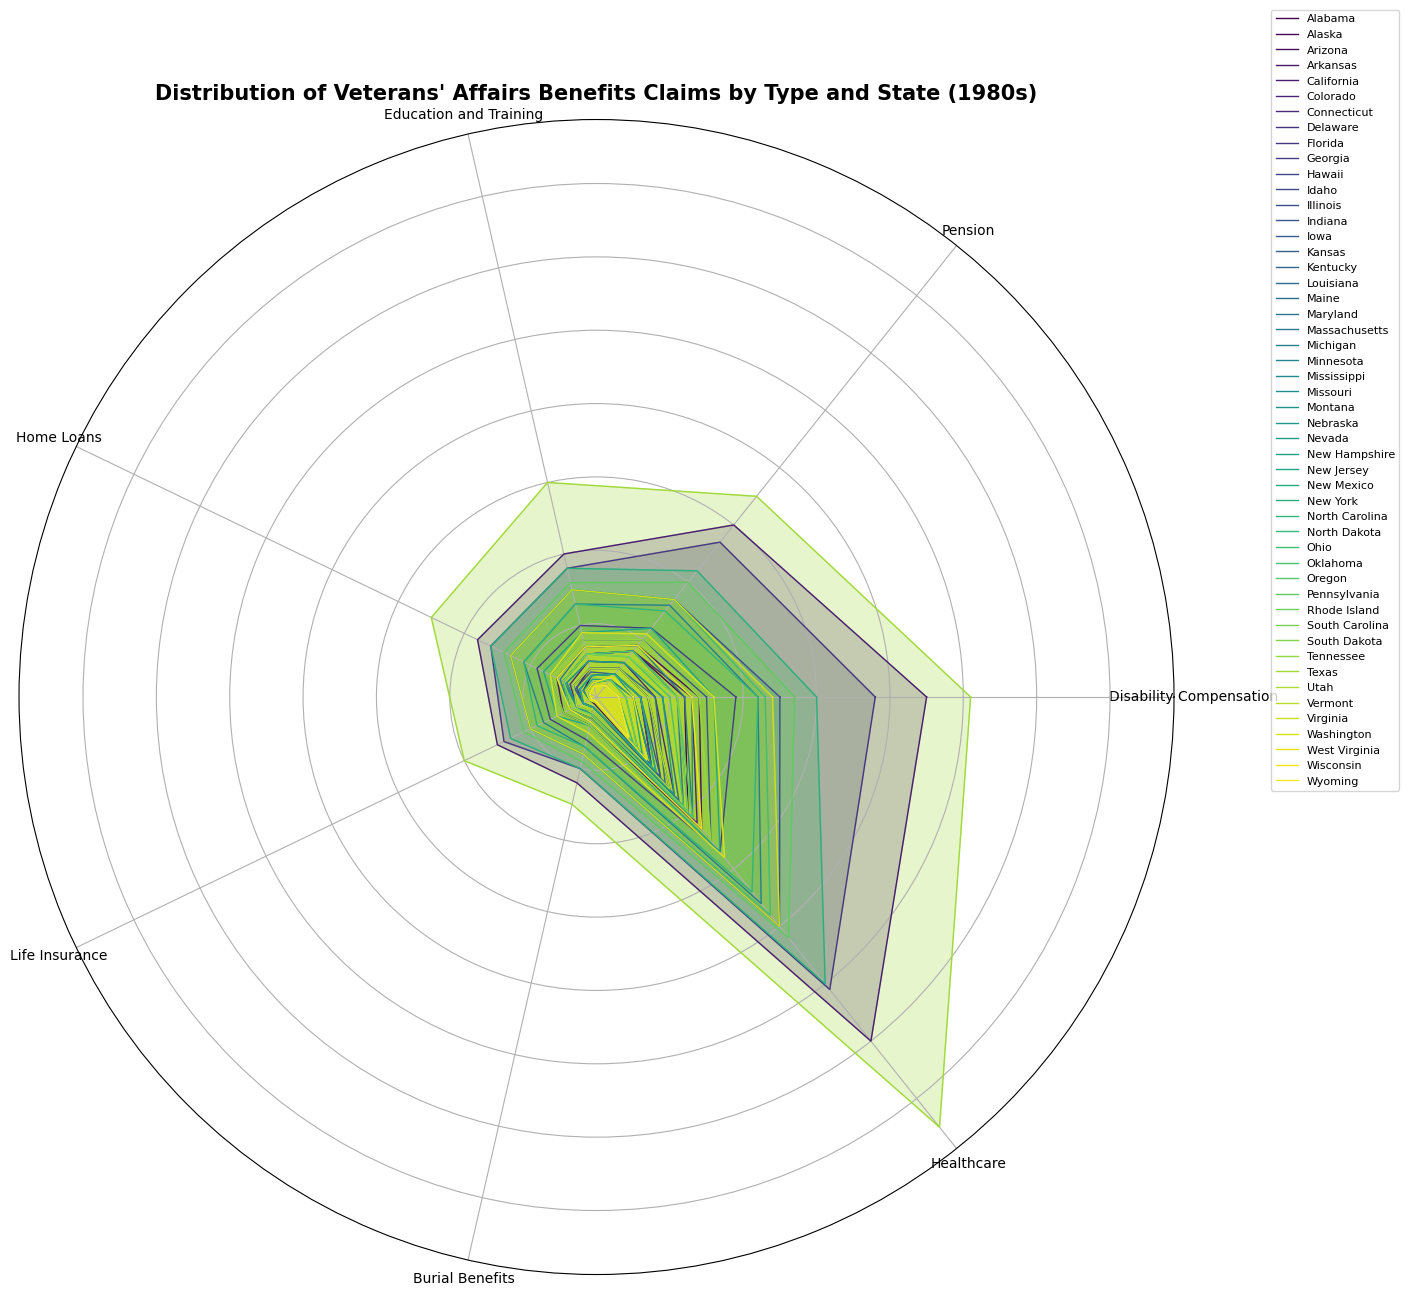What's the state with the highest total veterans' benefits claims? To find this, observe the overall size of each individual state's shape in the rose chart. The state with the largest shape represents the highest total claims.
Answer: Texas How do the Healthcare benefits claims compare between California and Texas? Identify the sections of the rose chart that represent Healthcare benefits for both California and Texas and compare their lengths.
Answer: Texas has higher Healthcare claims than California Which state claims more Disability Compensation benefits, Florida or New York? Locate the Disability Compensation sections for Florida and New York on the rose chart and compare their lengths.
Answer: Florida What is the combined total of Home Loans and Life Insurance benefits claims for Georgia? Identify the lengths of the Home Loans and Life Insurance sections in the rose chart for Georgia, then add them together.
Answer: 1600 Which benefit type has the smallest difference in claims between Indiana and Illinois? Observe the sections of the rose chart for Indiana and Illinois and compare the differences in length for each benefit type.
Answer: Education and Training Is the Pension claims section bigger for Alabama or Massachusetts? Locate the Pension section for both Alabama and Massachusetts in the rose chart and compare their lengths.
Answer: Massachusetts Which state has the most balanced distribution of benefits claims (similar lengths for all benefit types)? Look for a state in the rose chart where all segments seem to have nearly equal lengths.
Answer: Alaska How does the total number of Education and Training benefits claims compare between Arkansas and Tennessee? Check the Education and Training sections for both Arkansas and Tennessee and compare their lengths.
Answer: Tennessee has more What's the ratio of Burial Benefits claims in Pennsylvania compared to Rhode Island? Find the Burial Benefits sections for both Pennsylvania and Rhode Island, then calculate the ratio by comparing their lengths.
Answer: 12:1 Which states have higher Home Loans claims than South Carolina? Identify South Carolina's Home Loans section length and compare with other states to list those with longer sections.
Answer: Alabama, Arizona, California, Colorado, Florida, Georgia, Illinois, Indiana, Massachusetts, Michigan, Missouri, New Jersey, New York, North Carolina, Ohio, Pennsylvania, Texas, Virginia, Washington 